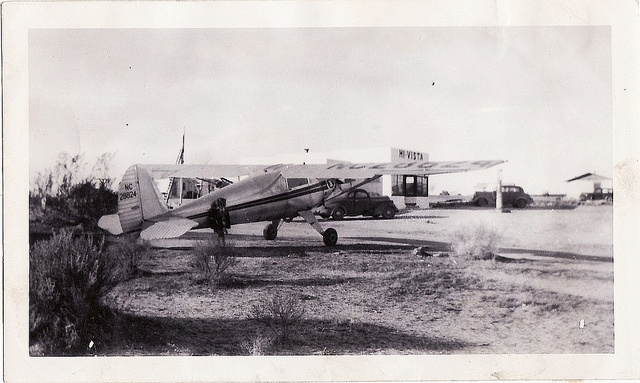Describe the objects in this image and their specific colors. I can see airplane in white, darkgray, black, gray, and lightgray tones, truck in white, black, gray, and darkgray tones, car in white, black, gray, and darkgray tones, car in white, gray, black, and darkgray tones, and car in white, gray, darkgray, black, and lightgray tones in this image. 